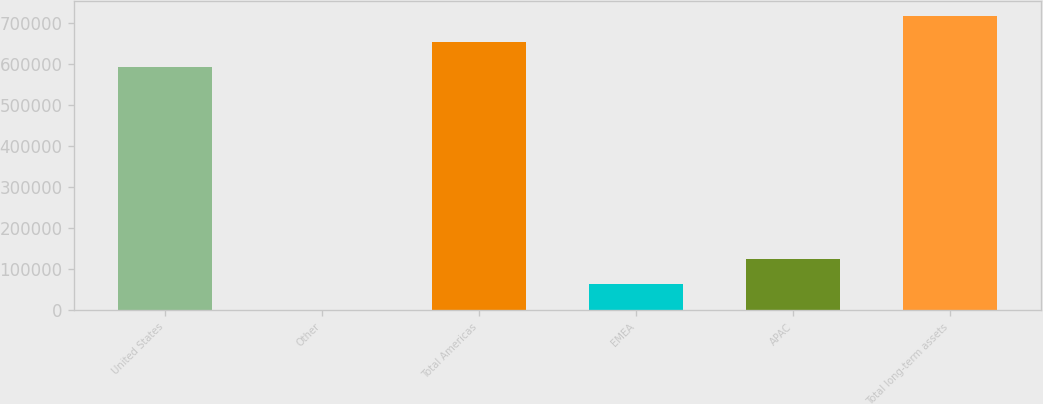Convert chart to OTSL. <chart><loc_0><loc_0><loc_500><loc_500><bar_chart><fcel>United States<fcel>Other<fcel>Total Americas<fcel>EMEA<fcel>APAC<fcel>Total long-term assets<nl><fcel>592554<fcel>1130<fcel>654633<fcel>63208.7<fcel>125287<fcel>716711<nl></chart> 